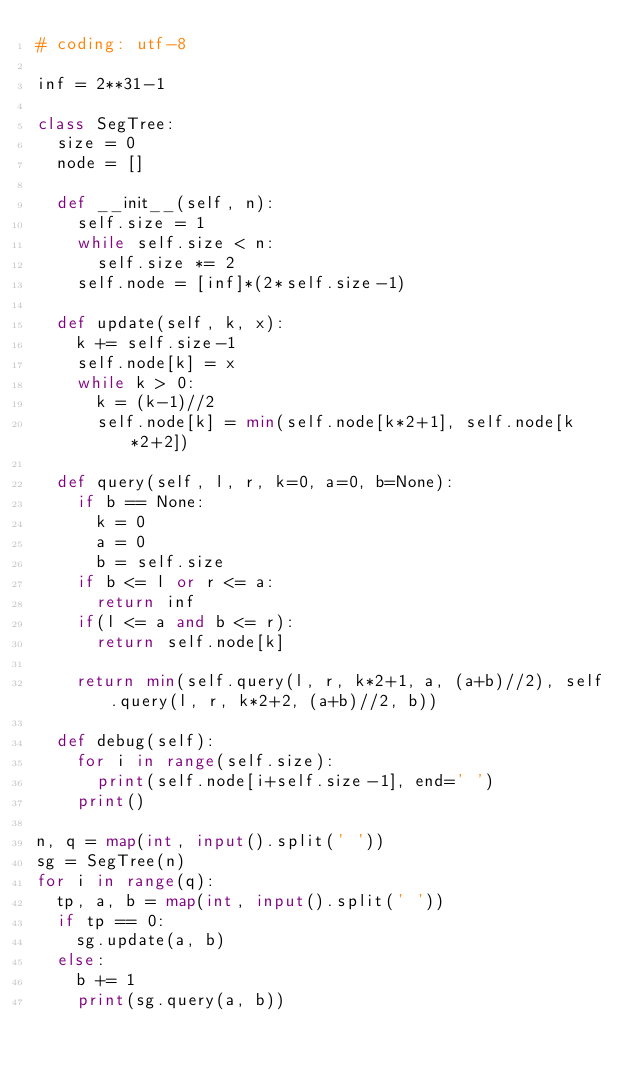Convert code to text. <code><loc_0><loc_0><loc_500><loc_500><_Python_># coding: utf-8

inf = 2**31-1

class SegTree:
  size = 0
  node = []

  def __init__(self, n):
    self.size = 1
    while self.size < n:
      self.size *= 2
    self.node = [inf]*(2*self.size-1)
  
  def update(self, k, x):
    k += self.size-1
    self.node[k] = x
    while k > 0:
      k = (k-1)//2
      self.node[k] = min(self.node[k*2+1], self.node[k*2+2])
  
  def query(self, l, r, k=0, a=0, b=None):
    if b == None:
      k = 0
      a = 0
      b = self.size
    if b <= l or r <= a:
      return inf
    if(l <= a and b <= r):
      return self.node[k]
    
    return min(self.query(l, r, k*2+1, a, (a+b)//2), self.query(l, r, k*2+2, (a+b)//2, b))
  
  def debug(self):
    for i in range(self.size):
      print(self.node[i+self.size-1], end=' ')
    print()

n, q = map(int, input().split(' '))
sg = SegTree(n)
for i in range(q):
  tp, a, b = map(int, input().split(' '))
  if tp == 0:
    sg.update(a, b)
  else:
    b += 1
    print(sg.query(a, b))

</code> 